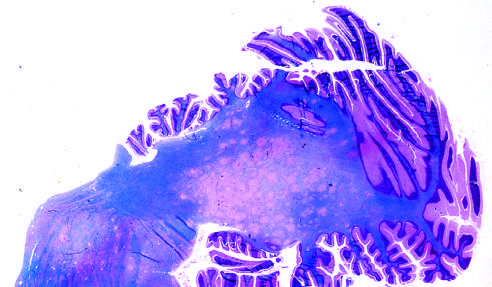s low-power view of a cross section of a skin blister showing the epidermis stain for myelin showing irregular, poorly defined areas of demyelination, which become confluent in places?
Answer the question using a single word or phrase. No 